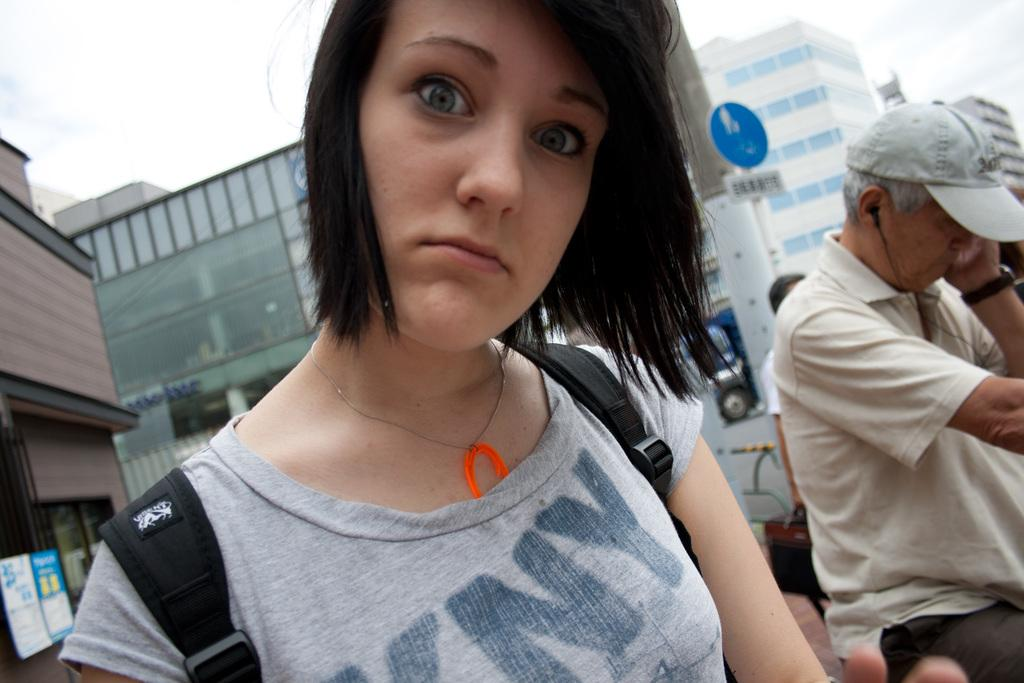Who is the main subject in the foreground of the image? There is a woman in the foreground of the image. What is the woman doing in the image? The woman is looking at someone. What is the woman wearing in the image? The woman is wearing a bag. What can be seen in the background of the image? There are buildings in the background of the image. Can you tell me how many basketballs are visible in the image? There are no basketballs present in the image. What type of current is flowing through the woman's bag in the image? There is no current present in the image, and the woman's bag does not appear to be related to any electrical or water current. 